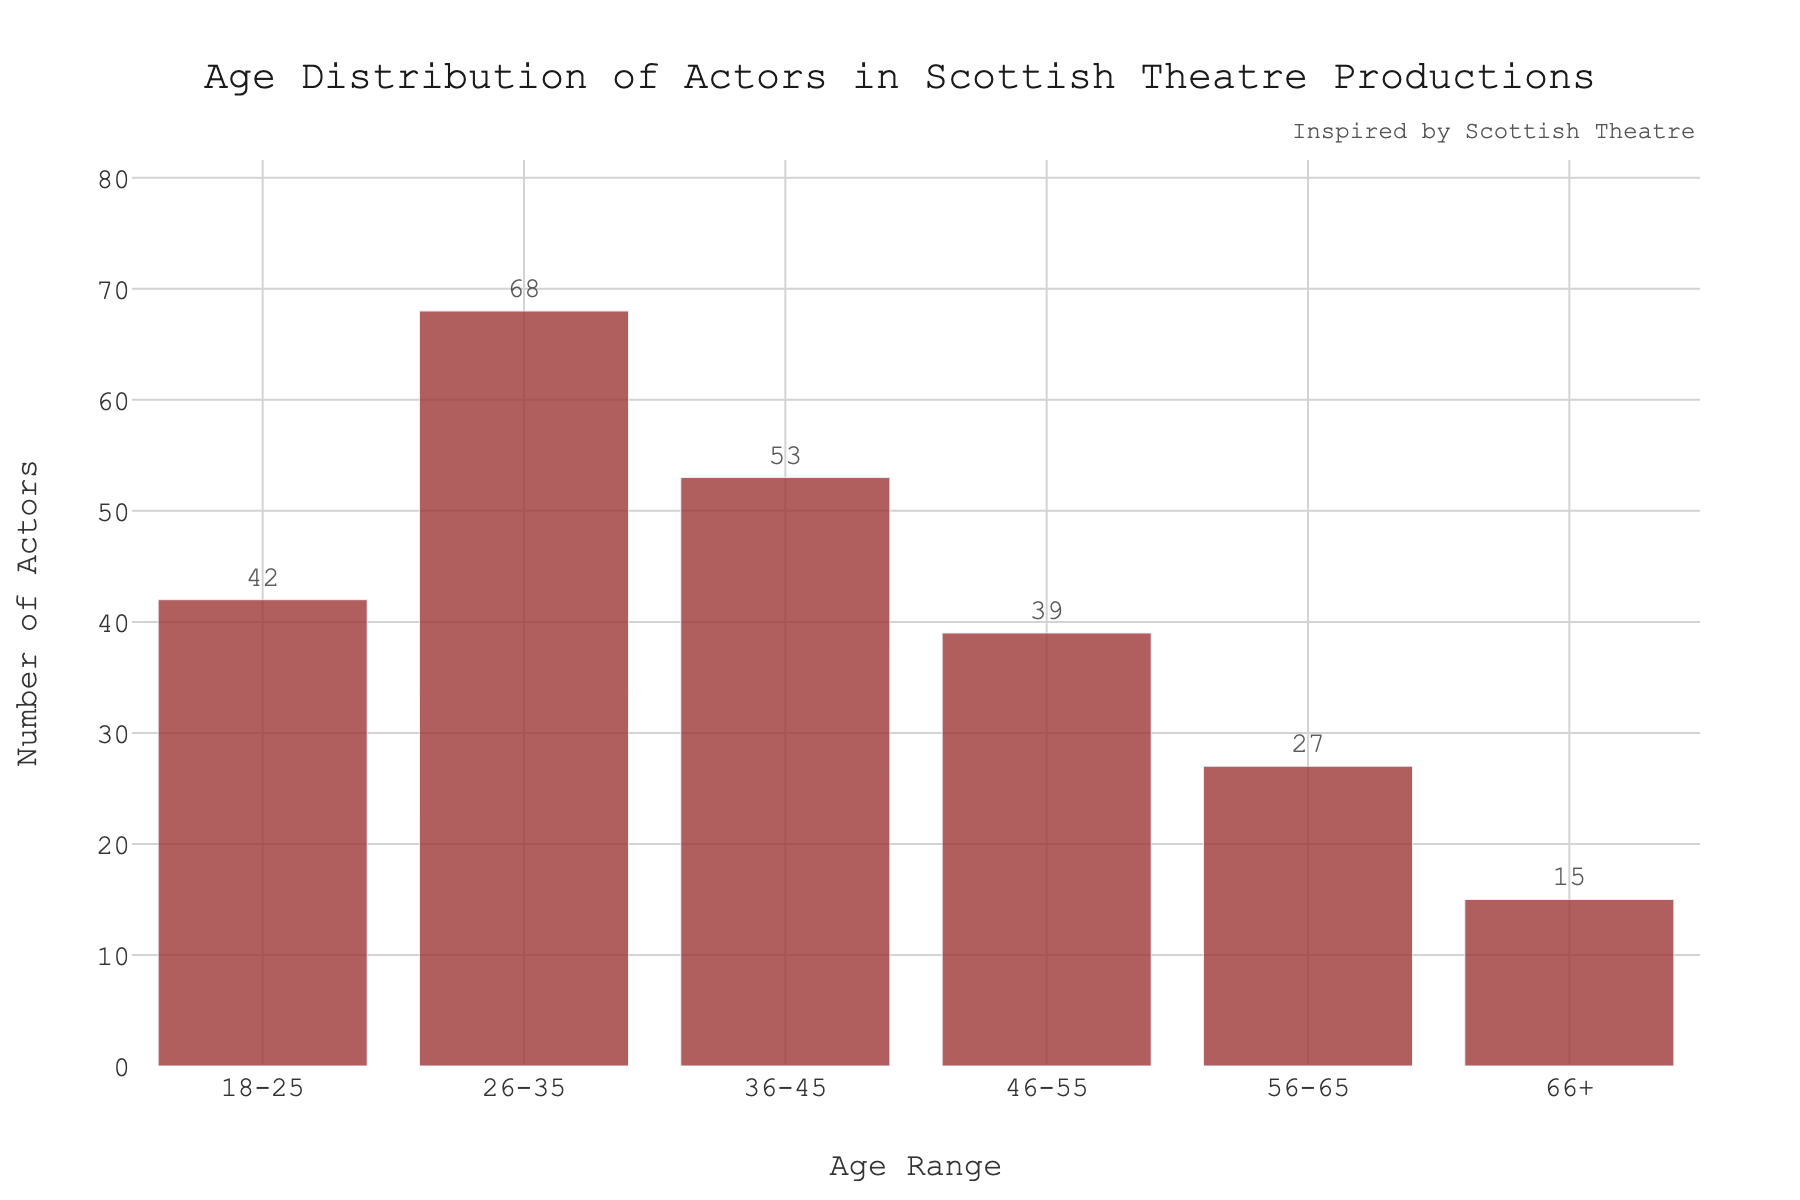What is the title of the plot? The title of the plot is displayed prominently at the top center of the figure. It states the main subject of the data being presented.
Answer: Age Distribution of Actors in Scottish Theatre Productions Which age range has the highest number of actors? By looking at the height of the bars, the bar for '26-35' range is the highest, indicating it has the most actors.
Answer: 26-35 What is the number of actors in the 18-25 age range? The height of the bar for the '18-25' range corresponds to the number on top of it, which indicates the count of actors in that range.
Answer: 42 How many age ranges are represented in the histogram? Count the distinct bars on the x-axis. Each bar represents an age range. There are six distinct bars.
Answer: 6 Which age range has the lowest number of actors? By observing the height of the bars, the '66+' range has the shortest bar, indicating the lowest number of actors.
Answer: 66+ What is the difference in the number of actors between the 26-35 and 56-65 age ranges? Subtract the number of actors in the '56-65' age range (27) from the number of actors in the '26-35' age range (68).
Answer: 41 What is the combined number of actors in the age ranges below 36 years old? Sum the number of actors in the '18-25' (42) and '26-35' (68) age ranges. 42 + 68 = 110
Answer: 110 Which age range has the second-highest number of actors? By comparing the heights of the bars, the '36-45' range is second-highest after '26-35'.
Answer: 36-45 Is the number of actors in the 36-45 age range greater than in the 46-55 age range? By comparing the heights of the respective bars, the '36-45' bar is taller than the '46-55' bar.
Answer: Yes What is the average number of actors across all age ranges? Add the number of actors in all age ranges and divide by the number of age ranges: (42 + 68 + 53 + 39 + 27 + 15) / 6 = 40.67.
Answer: 40.67 